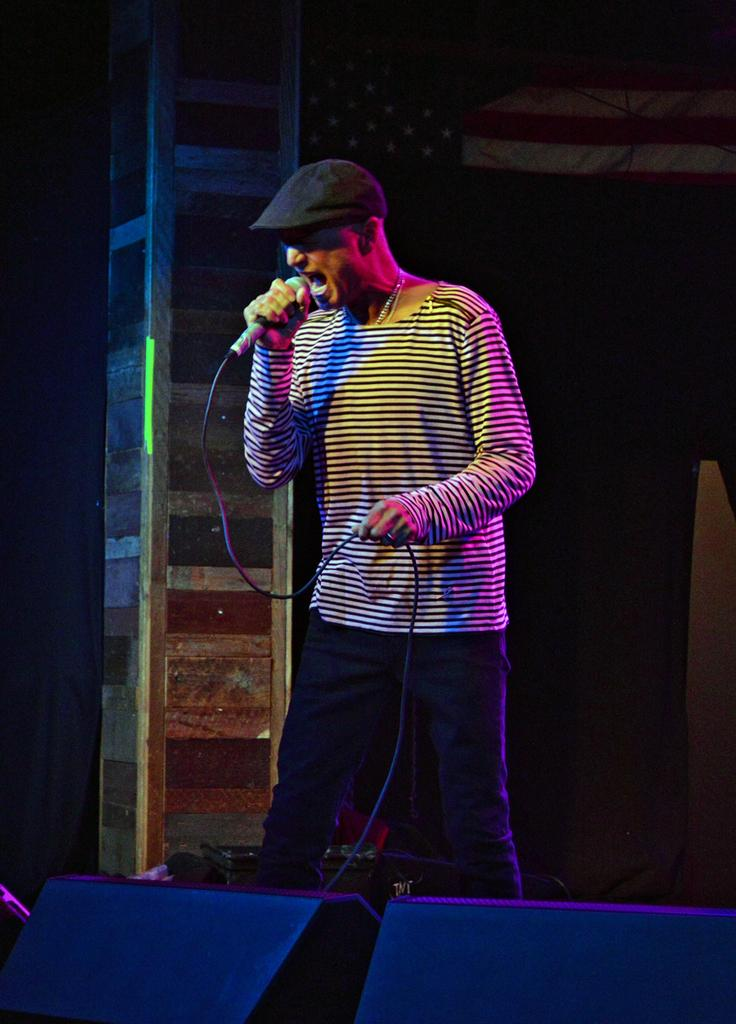What is the man in the image doing? The man is standing in the image and holding a mic in his hand. What might the man be using the mic for? The man might be using the mic for speaking or singing, as there are speakers on the stage in the image. How many times does the man stretch his eye in the image? There is no indication in the image that the man is stretching his eye, and therefore no such action can be observed. 